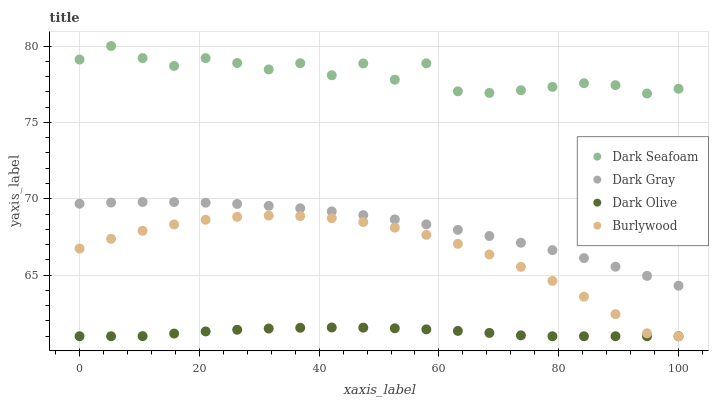Does Dark Olive have the minimum area under the curve?
Answer yes or no. Yes. Does Dark Seafoam have the maximum area under the curve?
Answer yes or no. Yes. Does Burlywood have the minimum area under the curve?
Answer yes or no. No. Does Burlywood have the maximum area under the curve?
Answer yes or no. No. Is Dark Olive the smoothest?
Answer yes or no. Yes. Is Dark Seafoam the roughest?
Answer yes or no. Yes. Is Burlywood the smoothest?
Answer yes or no. No. Is Burlywood the roughest?
Answer yes or no. No. Does Burlywood have the lowest value?
Answer yes or no. Yes. Does Dark Seafoam have the lowest value?
Answer yes or no. No. Does Dark Seafoam have the highest value?
Answer yes or no. Yes. Does Burlywood have the highest value?
Answer yes or no. No. Is Dark Gray less than Dark Seafoam?
Answer yes or no. Yes. Is Dark Seafoam greater than Dark Olive?
Answer yes or no. Yes. Does Dark Olive intersect Burlywood?
Answer yes or no. Yes. Is Dark Olive less than Burlywood?
Answer yes or no. No. Is Dark Olive greater than Burlywood?
Answer yes or no. No. Does Dark Gray intersect Dark Seafoam?
Answer yes or no. No. 